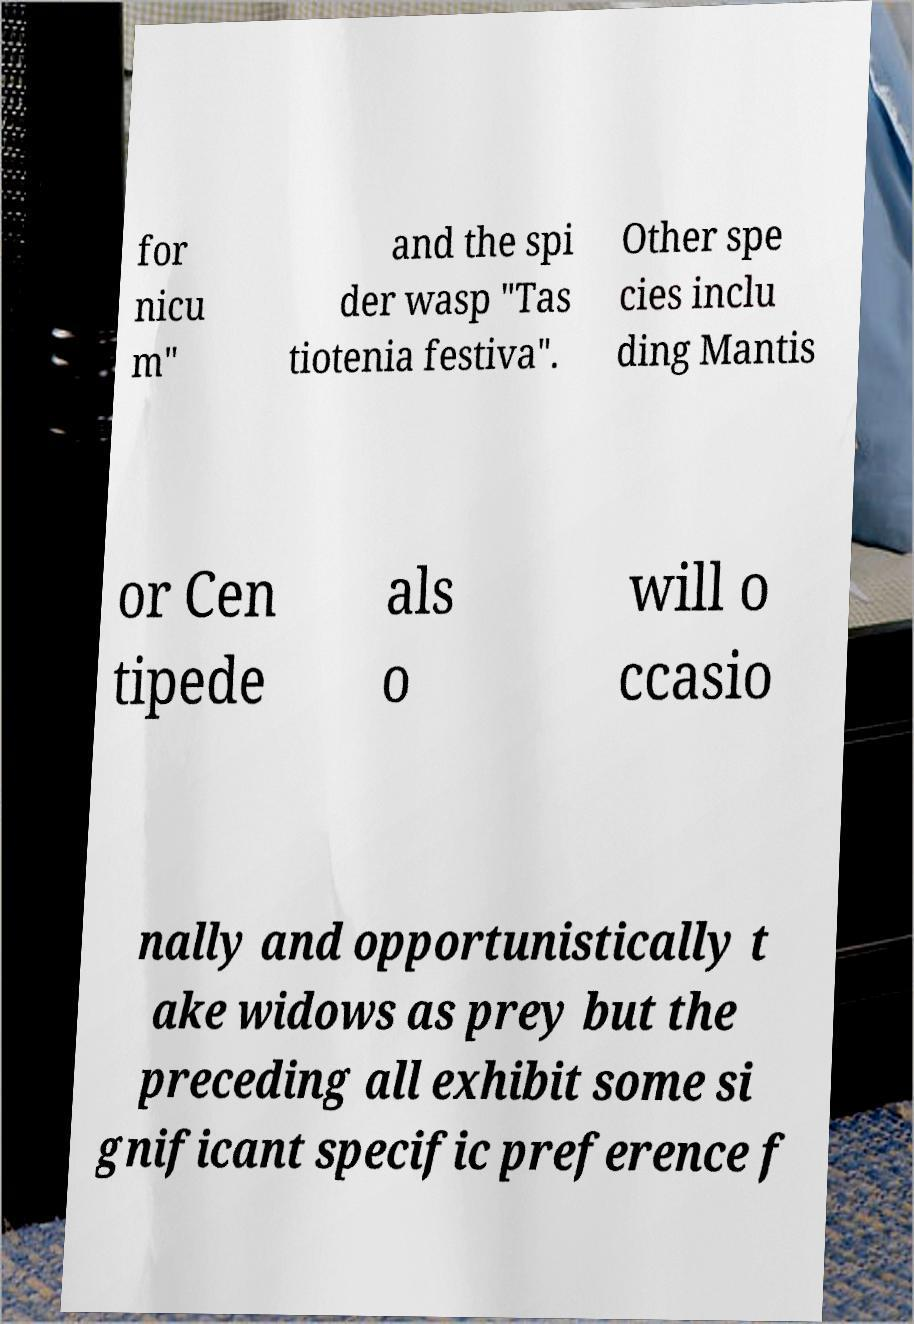Could you extract and type out the text from this image? for nicu m" and the spi der wasp "Tas tiotenia festiva". Other spe cies inclu ding Mantis or Cen tipede als o will o ccasio nally and opportunistically t ake widows as prey but the preceding all exhibit some si gnificant specific preference f 